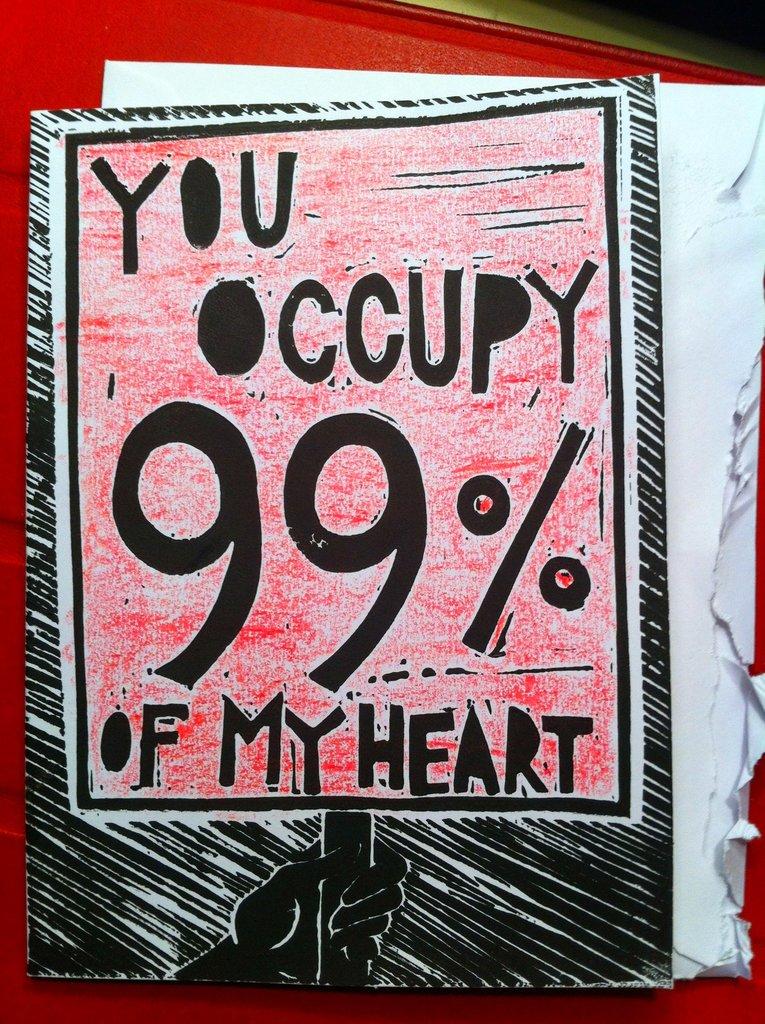What percentage is cited?
Make the answer very short. 99%. Who occupies 99% of my heart?
Keep it short and to the point. You. 